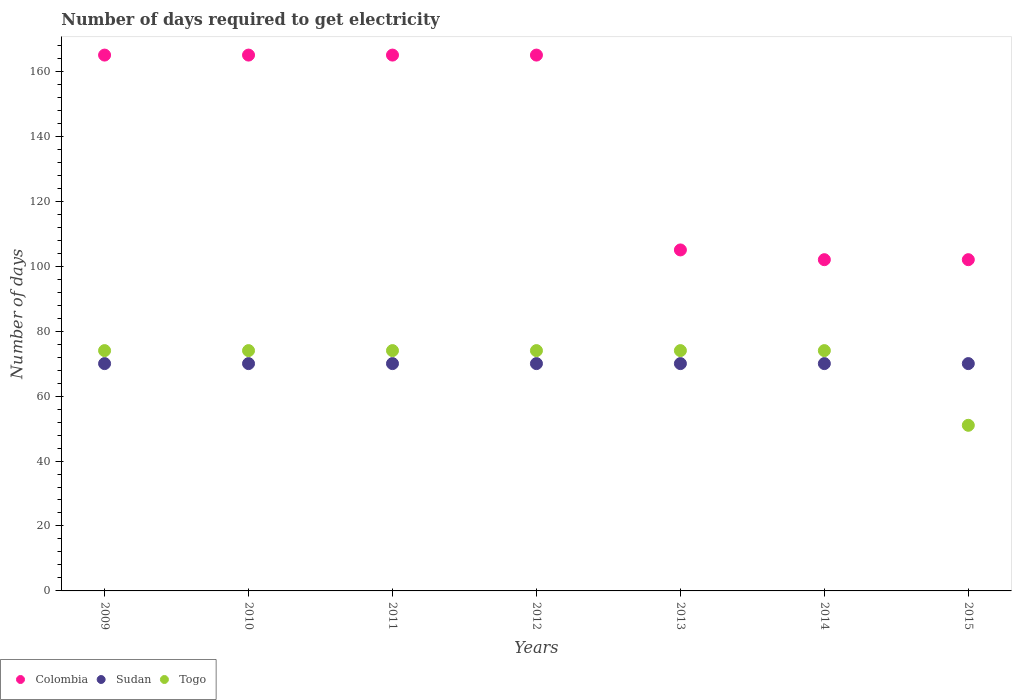How many different coloured dotlines are there?
Your response must be concise. 3. Is the number of dotlines equal to the number of legend labels?
Your answer should be very brief. Yes. What is the number of days required to get electricity in in Colombia in 2015?
Your answer should be very brief. 102. Across all years, what is the maximum number of days required to get electricity in in Colombia?
Provide a succinct answer. 165. Across all years, what is the minimum number of days required to get electricity in in Colombia?
Offer a terse response. 102. In which year was the number of days required to get electricity in in Togo minimum?
Make the answer very short. 2015. What is the total number of days required to get electricity in in Colombia in the graph?
Provide a succinct answer. 969. What is the difference between the number of days required to get electricity in in Togo in 2013 and the number of days required to get electricity in in Sudan in 2009?
Offer a very short reply. 4. What is the average number of days required to get electricity in in Togo per year?
Your response must be concise. 70.71. In the year 2009, what is the difference between the number of days required to get electricity in in Togo and number of days required to get electricity in in Colombia?
Offer a very short reply. -91. In how many years, is the number of days required to get electricity in in Colombia greater than 24 days?
Keep it short and to the point. 7. What is the ratio of the number of days required to get electricity in in Togo in 2010 to that in 2014?
Offer a terse response. 1. Is the number of days required to get electricity in in Colombia in 2013 less than that in 2015?
Make the answer very short. No. Does the number of days required to get electricity in in Togo monotonically increase over the years?
Ensure brevity in your answer.  No. Is the number of days required to get electricity in in Colombia strictly greater than the number of days required to get electricity in in Togo over the years?
Your answer should be compact. Yes. Is the number of days required to get electricity in in Colombia strictly less than the number of days required to get electricity in in Sudan over the years?
Offer a very short reply. No. How many dotlines are there?
Provide a short and direct response. 3. How many years are there in the graph?
Your answer should be very brief. 7. What is the difference between two consecutive major ticks on the Y-axis?
Your answer should be compact. 20. Does the graph contain any zero values?
Your response must be concise. No. Does the graph contain grids?
Provide a short and direct response. No. Where does the legend appear in the graph?
Make the answer very short. Bottom left. How many legend labels are there?
Your response must be concise. 3. How are the legend labels stacked?
Your answer should be compact. Horizontal. What is the title of the graph?
Your answer should be compact. Number of days required to get electricity. Does "Qatar" appear as one of the legend labels in the graph?
Offer a very short reply. No. What is the label or title of the X-axis?
Provide a succinct answer. Years. What is the label or title of the Y-axis?
Offer a terse response. Number of days. What is the Number of days of Colombia in 2009?
Offer a terse response. 165. What is the Number of days in Sudan in 2009?
Your answer should be very brief. 70. What is the Number of days of Colombia in 2010?
Make the answer very short. 165. What is the Number of days of Togo in 2010?
Ensure brevity in your answer.  74. What is the Number of days of Colombia in 2011?
Offer a very short reply. 165. What is the Number of days in Colombia in 2012?
Make the answer very short. 165. What is the Number of days of Sudan in 2012?
Provide a short and direct response. 70. What is the Number of days in Colombia in 2013?
Give a very brief answer. 105. What is the Number of days of Sudan in 2013?
Provide a short and direct response. 70. What is the Number of days in Togo in 2013?
Provide a succinct answer. 74. What is the Number of days in Colombia in 2014?
Provide a succinct answer. 102. What is the Number of days of Colombia in 2015?
Offer a very short reply. 102. What is the Number of days of Togo in 2015?
Your answer should be compact. 51. Across all years, what is the maximum Number of days in Colombia?
Keep it short and to the point. 165. Across all years, what is the maximum Number of days in Togo?
Make the answer very short. 74. Across all years, what is the minimum Number of days of Colombia?
Offer a terse response. 102. Across all years, what is the minimum Number of days in Togo?
Offer a terse response. 51. What is the total Number of days in Colombia in the graph?
Your answer should be very brief. 969. What is the total Number of days of Sudan in the graph?
Give a very brief answer. 490. What is the total Number of days of Togo in the graph?
Offer a very short reply. 495. What is the difference between the Number of days of Togo in 2009 and that in 2010?
Keep it short and to the point. 0. What is the difference between the Number of days of Sudan in 2009 and that in 2011?
Offer a very short reply. 0. What is the difference between the Number of days in Colombia in 2009 and that in 2012?
Provide a succinct answer. 0. What is the difference between the Number of days of Sudan in 2009 and that in 2012?
Give a very brief answer. 0. What is the difference between the Number of days of Togo in 2009 and that in 2012?
Keep it short and to the point. 0. What is the difference between the Number of days in Colombia in 2009 and that in 2013?
Offer a very short reply. 60. What is the difference between the Number of days in Sudan in 2009 and that in 2013?
Your answer should be compact. 0. What is the difference between the Number of days of Colombia in 2009 and that in 2014?
Your response must be concise. 63. What is the difference between the Number of days in Togo in 2009 and that in 2014?
Ensure brevity in your answer.  0. What is the difference between the Number of days in Sudan in 2009 and that in 2015?
Keep it short and to the point. 0. What is the difference between the Number of days in Togo in 2009 and that in 2015?
Your response must be concise. 23. What is the difference between the Number of days in Colombia in 2010 and that in 2011?
Provide a short and direct response. 0. What is the difference between the Number of days of Sudan in 2010 and that in 2011?
Offer a terse response. 0. What is the difference between the Number of days in Togo in 2010 and that in 2011?
Provide a short and direct response. 0. What is the difference between the Number of days in Colombia in 2010 and that in 2012?
Keep it short and to the point. 0. What is the difference between the Number of days of Sudan in 2010 and that in 2012?
Provide a short and direct response. 0. What is the difference between the Number of days in Sudan in 2010 and that in 2013?
Provide a succinct answer. 0. What is the difference between the Number of days in Togo in 2010 and that in 2014?
Offer a very short reply. 0. What is the difference between the Number of days of Colombia in 2010 and that in 2015?
Ensure brevity in your answer.  63. What is the difference between the Number of days of Sudan in 2010 and that in 2015?
Your response must be concise. 0. What is the difference between the Number of days in Togo in 2010 and that in 2015?
Your answer should be compact. 23. What is the difference between the Number of days of Togo in 2011 and that in 2012?
Ensure brevity in your answer.  0. What is the difference between the Number of days of Sudan in 2011 and that in 2013?
Your response must be concise. 0. What is the difference between the Number of days in Togo in 2011 and that in 2013?
Keep it short and to the point. 0. What is the difference between the Number of days in Colombia in 2011 and that in 2015?
Make the answer very short. 63. What is the difference between the Number of days in Sudan in 2011 and that in 2015?
Provide a short and direct response. 0. What is the difference between the Number of days in Sudan in 2012 and that in 2013?
Your answer should be compact. 0. What is the difference between the Number of days in Togo in 2012 and that in 2013?
Keep it short and to the point. 0. What is the difference between the Number of days of Colombia in 2012 and that in 2014?
Provide a succinct answer. 63. What is the difference between the Number of days of Sudan in 2012 and that in 2014?
Provide a succinct answer. 0. What is the difference between the Number of days in Sudan in 2012 and that in 2015?
Your response must be concise. 0. What is the difference between the Number of days in Sudan in 2013 and that in 2014?
Offer a terse response. 0. What is the difference between the Number of days in Colombia in 2014 and that in 2015?
Offer a very short reply. 0. What is the difference between the Number of days in Colombia in 2009 and the Number of days in Togo in 2010?
Provide a succinct answer. 91. What is the difference between the Number of days in Colombia in 2009 and the Number of days in Sudan in 2011?
Offer a very short reply. 95. What is the difference between the Number of days of Colombia in 2009 and the Number of days of Togo in 2011?
Keep it short and to the point. 91. What is the difference between the Number of days in Sudan in 2009 and the Number of days in Togo in 2011?
Your answer should be very brief. -4. What is the difference between the Number of days in Colombia in 2009 and the Number of days in Sudan in 2012?
Give a very brief answer. 95. What is the difference between the Number of days of Colombia in 2009 and the Number of days of Togo in 2012?
Give a very brief answer. 91. What is the difference between the Number of days of Colombia in 2009 and the Number of days of Togo in 2013?
Your response must be concise. 91. What is the difference between the Number of days of Colombia in 2009 and the Number of days of Sudan in 2014?
Ensure brevity in your answer.  95. What is the difference between the Number of days in Colombia in 2009 and the Number of days in Togo in 2014?
Your response must be concise. 91. What is the difference between the Number of days in Sudan in 2009 and the Number of days in Togo in 2014?
Provide a short and direct response. -4. What is the difference between the Number of days in Colombia in 2009 and the Number of days in Sudan in 2015?
Your answer should be compact. 95. What is the difference between the Number of days of Colombia in 2009 and the Number of days of Togo in 2015?
Your response must be concise. 114. What is the difference between the Number of days in Sudan in 2009 and the Number of days in Togo in 2015?
Your answer should be very brief. 19. What is the difference between the Number of days in Colombia in 2010 and the Number of days in Togo in 2011?
Offer a very short reply. 91. What is the difference between the Number of days in Colombia in 2010 and the Number of days in Togo in 2012?
Give a very brief answer. 91. What is the difference between the Number of days of Colombia in 2010 and the Number of days of Sudan in 2013?
Offer a terse response. 95. What is the difference between the Number of days in Colombia in 2010 and the Number of days in Togo in 2013?
Ensure brevity in your answer.  91. What is the difference between the Number of days of Sudan in 2010 and the Number of days of Togo in 2013?
Provide a short and direct response. -4. What is the difference between the Number of days in Colombia in 2010 and the Number of days in Sudan in 2014?
Your answer should be compact. 95. What is the difference between the Number of days in Colombia in 2010 and the Number of days in Togo in 2014?
Offer a very short reply. 91. What is the difference between the Number of days of Colombia in 2010 and the Number of days of Sudan in 2015?
Ensure brevity in your answer.  95. What is the difference between the Number of days in Colombia in 2010 and the Number of days in Togo in 2015?
Offer a very short reply. 114. What is the difference between the Number of days in Sudan in 2010 and the Number of days in Togo in 2015?
Make the answer very short. 19. What is the difference between the Number of days in Colombia in 2011 and the Number of days in Sudan in 2012?
Keep it short and to the point. 95. What is the difference between the Number of days in Colombia in 2011 and the Number of days in Togo in 2012?
Provide a short and direct response. 91. What is the difference between the Number of days in Sudan in 2011 and the Number of days in Togo in 2012?
Keep it short and to the point. -4. What is the difference between the Number of days of Colombia in 2011 and the Number of days of Sudan in 2013?
Your answer should be compact. 95. What is the difference between the Number of days of Colombia in 2011 and the Number of days of Togo in 2013?
Your answer should be compact. 91. What is the difference between the Number of days in Colombia in 2011 and the Number of days in Togo in 2014?
Your response must be concise. 91. What is the difference between the Number of days in Sudan in 2011 and the Number of days in Togo in 2014?
Your answer should be very brief. -4. What is the difference between the Number of days of Colombia in 2011 and the Number of days of Sudan in 2015?
Give a very brief answer. 95. What is the difference between the Number of days of Colombia in 2011 and the Number of days of Togo in 2015?
Provide a succinct answer. 114. What is the difference between the Number of days in Colombia in 2012 and the Number of days in Sudan in 2013?
Offer a terse response. 95. What is the difference between the Number of days of Colombia in 2012 and the Number of days of Togo in 2013?
Your answer should be compact. 91. What is the difference between the Number of days in Sudan in 2012 and the Number of days in Togo in 2013?
Your answer should be very brief. -4. What is the difference between the Number of days of Colombia in 2012 and the Number of days of Togo in 2014?
Your answer should be very brief. 91. What is the difference between the Number of days in Colombia in 2012 and the Number of days in Togo in 2015?
Your response must be concise. 114. What is the difference between the Number of days in Colombia in 2013 and the Number of days in Togo in 2014?
Your answer should be compact. 31. What is the difference between the Number of days of Colombia in 2013 and the Number of days of Sudan in 2015?
Give a very brief answer. 35. What is the difference between the Number of days in Colombia in 2013 and the Number of days in Togo in 2015?
Provide a short and direct response. 54. What is the difference between the Number of days in Colombia in 2014 and the Number of days in Sudan in 2015?
Keep it short and to the point. 32. What is the difference between the Number of days of Colombia in 2014 and the Number of days of Togo in 2015?
Make the answer very short. 51. What is the difference between the Number of days in Sudan in 2014 and the Number of days in Togo in 2015?
Give a very brief answer. 19. What is the average Number of days of Colombia per year?
Offer a terse response. 138.43. What is the average Number of days in Togo per year?
Keep it short and to the point. 70.71. In the year 2009, what is the difference between the Number of days in Colombia and Number of days in Togo?
Provide a succinct answer. 91. In the year 2010, what is the difference between the Number of days of Colombia and Number of days of Sudan?
Offer a very short reply. 95. In the year 2010, what is the difference between the Number of days of Colombia and Number of days of Togo?
Provide a short and direct response. 91. In the year 2011, what is the difference between the Number of days of Colombia and Number of days of Togo?
Your answer should be compact. 91. In the year 2011, what is the difference between the Number of days of Sudan and Number of days of Togo?
Make the answer very short. -4. In the year 2012, what is the difference between the Number of days in Colombia and Number of days in Sudan?
Keep it short and to the point. 95. In the year 2012, what is the difference between the Number of days in Colombia and Number of days in Togo?
Your response must be concise. 91. In the year 2013, what is the difference between the Number of days in Colombia and Number of days in Togo?
Your answer should be compact. 31. In the year 2013, what is the difference between the Number of days in Sudan and Number of days in Togo?
Provide a short and direct response. -4. In the year 2014, what is the difference between the Number of days of Colombia and Number of days of Sudan?
Offer a very short reply. 32. In the year 2015, what is the difference between the Number of days of Sudan and Number of days of Togo?
Your answer should be very brief. 19. What is the ratio of the Number of days of Sudan in 2009 to that in 2010?
Your response must be concise. 1. What is the ratio of the Number of days in Togo in 2009 to that in 2010?
Provide a succinct answer. 1. What is the ratio of the Number of days of Colombia in 2009 to that in 2011?
Provide a short and direct response. 1. What is the ratio of the Number of days in Colombia in 2009 to that in 2012?
Provide a short and direct response. 1. What is the ratio of the Number of days of Sudan in 2009 to that in 2012?
Make the answer very short. 1. What is the ratio of the Number of days of Togo in 2009 to that in 2012?
Your answer should be very brief. 1. What is the ratio of the Number of days of Colombia in 2009 to that in 2013?
Give a very brief answer. 1.57. What is the ratio of the Number of days in Togo in 2009 to that in 2013?
Offer a terse response. 1. What is the ratio of the Number of days in Colombia in 2009 to that in 2014?
Make the answer very short. 1.62. What is the ratio of the Number of days of Sudan in 2009 to that in 2014?
Provide a succinct answer. 1. What is the ratio of the Number of days of Colombia in 2009 to that in 2015?
Your answer should be compact. 1.62. What is the ratio of the Number of days in Sudan in 2009 to that in 2015?
Your response must be concise. 1. What is the ratio of the Number of days of Togo in 2009 to that in 2015?
Give a very brief answer. 1.45. What is the ratio of the Number of days of Togo in 2010 to that in 2011?
Provide a short and direct response. 1. What is the ratio of the Number of days in Colombia in 2010 to that in 2012?
Provide a short and direct response. 1. What is the ratio of the Number of days in Colombia in 2010 to that in 2013?
Your answer should be compact. 1.57. What is the ratio of the Number of days of Colombia in 2010 to that in 2014?
Your answer should be compact. 1.62. What is the ratio of the Number of days in Sudan in 2010 to that in 2014?
Provide a short and direct response. 1. What is the ratio of the Number of days in Togo in 2010 to that in 2014?
Ensure brevity in your answer.  1. What is the ratio of the Number of days in Colombia in 2010 to that in 2015?
Ensure brevity in your answer.  1.62. What is the ratio of the Number of days in Sudan in 2010 to that in 2015?
Provide a succinct answer. 1. What is the ratio of the Number of days of Togo in 2010 to that in 2015?
Offer a terse response. 1.45. What is the ratio of the Number of days of Sudan in 2011 to that in 2012?
Ensure brevity in your answer.  1. What is the ratio of the Number of days of Togo in 2011 to that in 2012?
Your response must be concise. 1. What is the ratio of the Number of days in Colombia in 2011 to that in 2013?
Give a very brief answer. 1.57. What is the ratio of the Number of days in Sudan in 2011 to that in 2013?
Offer a terse response. 1. What is the ratio of the Number of days of Togo in 2011 to that in 2013?
Offer a terse response. 1. What is the ratio of the Number of days in Colombia in 2011 to that in 2014?
Ensure brevity in your answer.  1.62. What is the ratio of the Number of days of Colombia in 2011 to that in 2015?
Provide a succinct answer. 1.62. What is the ratio of the Number of days of Togo in 2011 to that in 2015?
Your answer should be very brief. 1.45. What is the ratio of the Number of days in Colombia in 2012 to that in 2013?
Give a very brief answer. 1.57. What is the ratio of the Number of days of Togo in 2012 to that in 2013?
Keep it short and to the point. 1. What is the ratio of the Number of days in Colombia in 2012 to that in 2014?
Offer a terse response. 1.62. What is the ratio of the Number of days of Sudan in 2012 to that in 2014?
Offer a terse response. 1. What is the ratio of the Number of days of Togo in 2012 to that in 2014?
Offer a terse response. 1. What is the ratio of the Number of days in Colombia in 2012 to that in 2015?
Keep it short and to the point. 1.62. What is the ratio of the Number of days in Sudan in 2012 to that in 2015?
Keep it short and to the point. 1. What is the ratio of the Number of days in Togo in 2012 to that in 2015?
Keep it short and to the point. 1.45. What is the ratio of the Number of days of Colombia in 2013 to that in 2014?
Make the answer very short. 1.03. What is the ratio of the Number of days of Sudan in 2013 to that in 2014?
Your answer should be compact. 1. What is the ratio of the Number of days in Togo in 2013 to that in 2014?
Make the answer very short. 1. What is the ratio of the Number of days of Colombia in 2013 to that in 2015?
Your response must be concise. 1.03. What is the ratio of the Number of days of Togo in 2013 to that in 2015?
Offer a terse response. 1.45. What is the ratio of the Number of days of Sudan in 2014 to that in 2015?
Provide a succinct answer. 1. What is the ratio of the Number of days of Togo in 2014 to that in 2015?
Give a very brief answer. 1.45. What is the difference between the highest and the second highest Number of days of Colombia?
Your answer should be compact. 0. What is the difference between the highest and the second highest Number of days of Sudan?
Keep it short and to the point. 0. What is the difference between the highest and the lowest Number of days in Sudan?
Your answer should be very brief. 0. 